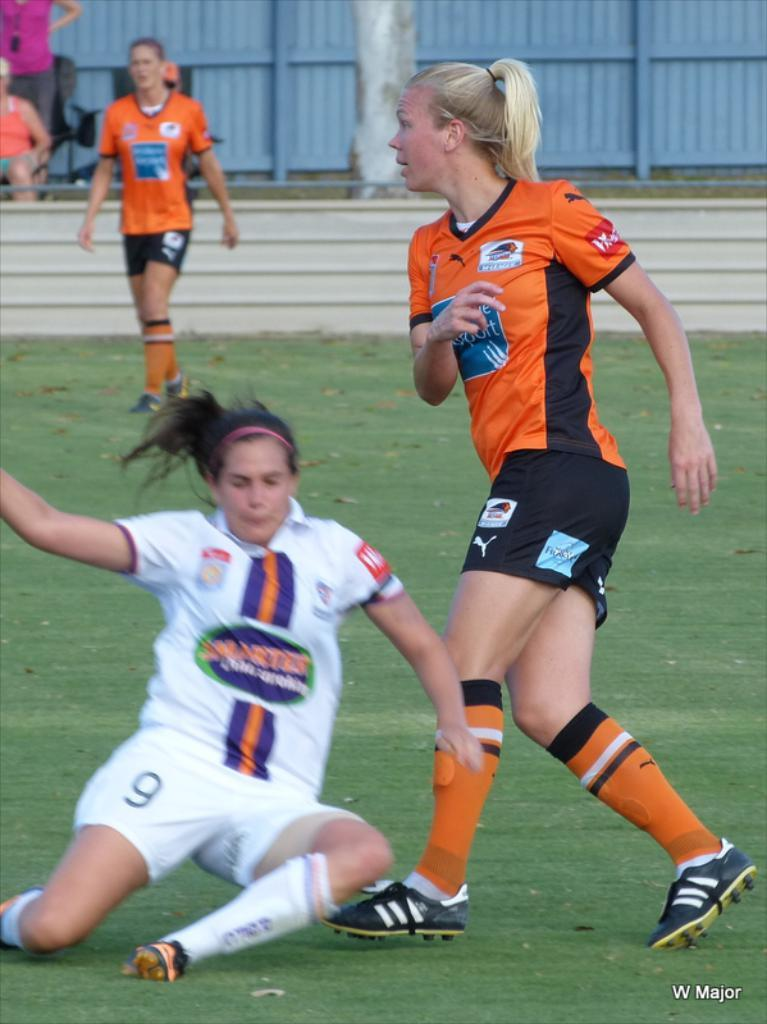Provide a one-sentence caption for the provided image. Soccer players wearing puma shorts and adidas shoes colliding with one another. 